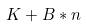Convert formula to latex. <formula><loc_0><loc_0><loc_500><loc_500>K + B * n</formula> 